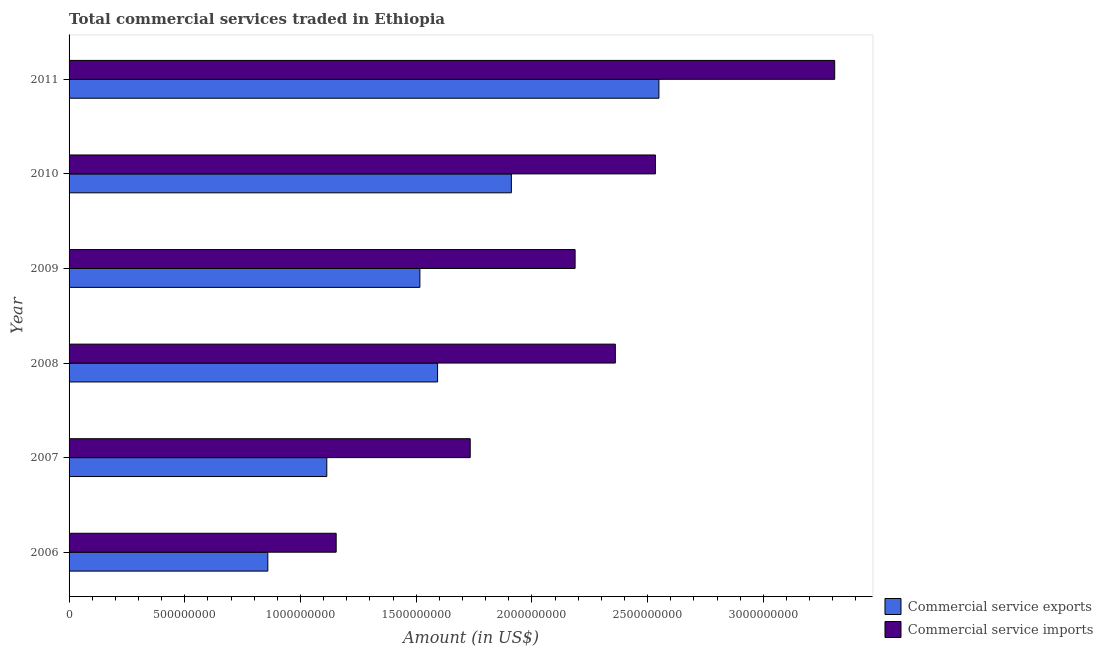How many groups of bars are there?
Offer a terse response. 6. How many bars are there on the 3rd tick from the bottom?
Make the answer very short. 2. What is the amount of commercial service exports in 2009?
Your answer should be very brief. 1.52e+09. Across all years, what is the maximum amount of commercial service imports?
Provide a short and direct response. 3.31e+09. Across all years, what is the minimum amount of commercial service exports?
Your answer should be very brief. 8.59e+08. In which year was the amount of commercial service exports minimum?
Make the answer very short. 2006. What is the total amount of commercial service exports in the graph?
Ensure brevity in your answer.  9.54e+09. What is the difference between the amount of commercial service exports in 2007 and that in 2008?
Your response must be concise. -4.79e+08. What is the difference between the amount of commercial service exports in 2006 and the amount of commercial service imports in 2010?
Keep it short and to the point. -1.67e+09. What is the average amount of commercial service imports per year?
Keep it short and to the point. 2.21e+09. In the year 2009, what is the difference between the amount of commercial service exports and amount of commercial service imports?
Give a very brief answer. -6.71e+08. What is the ratio of the amount of commercial service exports in 2008 to that in 2009?
Your answer should be very brief. 1.05. What is the difference between the highest and the second highest amount of commercial service exports?
Provide a short and direct response. 6.38e+08. What is the difference between the highest and the lowest amount of commercial service exports?
Make the answer very short. 1.69e+09. What does the 1st bar from the top in 2010 represents?
Make the answer very short. Commercial service imports. What does the 2nd bar from the bottom in 2007 represents?
Your response must be concise. Commercial service imports. How many bars are there?
Offer a very short reply. 12. Are all the bars in the graph horizontal?
Offer a terse response. Yes. How many years are there in the graph?
Make the answer very short. 6. Are the values on the major ticks of X-axis written in scientific E-notation?
Your answer should be compact. No. How are the legend labels stacked?
Your answer should be very brief. Vertical. What is the title of the graph?
Ensure brevity in your answer.  Total commercial services traded in Ethiopia. Does "Techinal cooperation" appear as one of the legend labels in the graph?
Make the answer very short. No. What is the label or title of the Y-axis?
Offer a very short reply. Year. What is the Amount (in US$) in Commercial service exports in 2006?
Ensure brevity in your answer.  8.59e+08. What is the Amount (in US$) in Commercial service imports in 2006?
Give a very brief answer. 1.15e+09. What is the Amount (in US$) in Commercial service exports in 2007?
Offer a terse response. 1.11e+09. What is the Amount (in US$) in Commercial service imports in 2007?
Ensure brevity in your answer.  1.73e+09. What is the Amount (in US$) in Commercial service exports in 2008?
Offer a terse response. 1.59e+09. What is the Amount (in US$) of Commercial service imports in 2008?
Offer a very short reply. 2.36e+09. What is the Amount (in US$) in Commercial service exports in 2009?
Provide a short and direct response. 1.52e+09. What is the Amount (in US$) of Commercial service imports in 2009?
Ensure brevity in your answer.  2.19e+09. What is the Amount (in US$) in Commercial service exports in 2010?
Ensure brevity in your answer.  1.91e+09. What is the Amount (in US$) of Commercial service imports in 2010?
Keep it short and to the point. 2.53e+09. What is the Amount (in US$) of Commercial service exports in 2011?
Ensure brevity in your answer.  2.55e+09. What is the Amount (in US$) of Commercial service imports in 2011?
Provide a succinct answer. 3.31e+09. Across all years, what is the maximum Amount (in US$) in Commercial service exports?
Offer a terse response. 2.55e+09. Across all years, what is the maximum Amount (in US$) in Commercial service imports?
Keep it short and to the point. 3.31e+09. Across all years, what is the minimum Amount (in US$) of Commercial service exports?
Offer a very short reply. 8.59e+08. Across all years, what is the minimum Amount (in US$) in Commercial service imports?
Provide a succinct answer. 1.15e+09. What is the total Amount (in US$) in Commercial service exports in the graph?
Offer a terse response. 9.54e+09. What is the total Amount (in US$) in Commercial service imports in the graph?
Your response must be concise. 1.33e+1. What is the difference between the Amount (in US$) in Commercial service exports in 2006 and that in 2007?
Provide a short and direct response. -2.55e+08. What is the difference between the Amount (in US$) of Commercial service imports in 2006 and that in 2007?
Provide a succinct answer. -5.79e+08. What is the difference between the Amount (in US$) in Commercial service exports in 2006 and that in 2008?
Keep it short and to the point. -7.34e+08. What is the difference between the Amount (in US$) of Commercial service imports in 2006 and that in 2008?
Provide a short and direct response. -1.21e+09. What is the difference between the Amount (in US$) in Commercial service exports in 2006 and that in 2009?
Keep it short and to the point. -6.57e+08. What is the difference between the Amount (in US$) of Commercial service imports in 2006 and that in 2009?
Give a very brief answer. -1.03e+09. What is the difference between the Amount (in US$) in Commercial service exports in 2006 and that in 2010?
Keep it short and to the point. -1.05e+09. What is the difference between the Amount (in US$) in Commercial service imports in 2006 and that in 2010?
Provide a succinct answer. -1.38e+09. What is the difference between the Amount (in US$) of Commercial service exports in 2006 and that in 2011?
Provide a short and direct response. -1.69e+09. What is the difference between the Amount (in US$) in Commercial service imports in 2006 and that in 2011?
Your response must be concise. -2.15e+09. What is the difference between the Amount (in US$) of Commercial service exports in 2007 and that in 2008?
Your response must be concise. -4.79e+08. What is the difference between the Amount (in US$) in Commercial service imports in 2007 and that in 2008?
Ensure brevity in your answer.  -6.27e+08. What is the difference between the Amount (in US$) in Commercial service exports in 2007 and that in 2009?
Give a very brief answer. -4.02e+08. What is the difference between the Amount (in US$) in Commercial service imports in 2007 and that in 2009?
Offer a terse response. -4.53e+08. What is the difference between the Amount (in US$) of Commercial service exports in 2007 and that in 2010?
Make the answer very short. -7.98e+08. What is the difference between the Amount (in US$) of Commercial service imports in 2007 and that in 2010?
Give a very brief answer. -8.00e+08. What is the difference between the Amount (in US$) of Commercial service exports in 2007 and that in 2011?
Your response must be concise. -1.44e+09. What is the difference between the Amount (in US$) in Commercial service imports in 2007 and that in 2011?
Offer a very short reply. -1.58e+09. What is the difference between the Amount (in US$) in Commercial service exports in 2008 and that in 2009?
Offer a terse response. 7.64e+07. What is the difference between the Amount (in US$) of Commercial service imports in 2008 and that in 2009?
Offer a terse response. 1.74e+08. What is the difference between the Amount (in US$) in Commercial service exports in 2008 and that in 2010?
Your answer should be compact. -3.19e+08. What is the difference between the Amount (in US$) in Commercial service imports in 2008 and that in 2010?
Provide a short and direct response. -1.73e+08. What is the difference between the Amount (in US$) in Commercial service exports in 2008 and that in 2011?
Provide a succinct answer. -9.56e+08. What is the difference between the Amount (in US$) of Commercial service imports in 2008 and that in 2011?
Keep it short and to the point. -9.48e+08. What is the difference between the Amount (in US$) of Commercial service exports in 2009 and that in 2010?
Offer a very short reply. -3.95e+08. What is the difference between the Amount (in US$) in Commercial service imports in 2009 and that in 2010?
Ensure brevity in your answer.  -3.47e+08. What is the difference between the Amount (in US$) in Commercial service exports in 2009 and that in 2011?
Offer a very short reply. -1.03e+09. What is the difference between the Amount (in US$) in Commercial service imports in 2009 and that in 2011?
Provide a short and direct response. -1.12e+09. What is the difference between the Amount (in US$) in Commercial service exports in 2010 and that in 2011?
Keep it short and to the point. -6.38e+08. What is the difference between the Amount (in US$) in Commercial service imports in 2010 and that in 2011?
Offer a terse response. -7.75e+08. What is the difference between the Amount (in US$) in Commercial service exports in 2006 and the Amount (in US$) in Commercial service imports in 2007?
Make the answer very short. -8.75e+08. What is the difference between the Amount (in US$) in Commercial service exports in 2006 and the Amount (in US$) in Commercial service imports in 2008?
Give a very brief answer. -1.50e+09. What is the difference between the Amount (in US$) of Commercial service exports in 2006 and the Amount (in US$) of Commercial service imports in 2009?
Keep it short and to the point. -1.33e+09. What is the difference between the Amount (in US$) in Commercial service exports in 2006 and the Amount (in US$) in Commercial service imports in 2010?
Offer a very short reply. -1.67e+09. What is the difference between the Amount (in US$) in Commercial service exports in 2006 and the Amount (in US$) in Commercial service imports in 2011?
Your answer should be very brief. -2.45e+09. What is the difference between the Amount (in US$) in Commercial service exports in 2007 and the Amount (in US$) in Commercial service imports in 2008?
Provide a short and direct response. -1.25e+09. What is the difference between the Amount (in US$) in Commercial service exports in 2007 and the Amount (in US$) in Commercial service imports in 2009?
Your answer should be compact. -1.07e+09. What is the difference between the Amount (in US$) of Commercial service exports in 2007 and the Amount (in US$) of Commercial service imports in 2010?
Provide a short and direct response. -1.42e+09. What is the difference between the Amount (in US$) of Commercial service exports in 2007 and the Amount (in US$) of Commercial service imports in 2011?
Ensure brevity in your answer.  -2.19e+09. What is the difference between the Amount (in US$) of Commercial service exports in 2008 and the Amount (in US$) of Commercial service imports in 2009?
Offer a terse response. -5.94e+08. What is the difference between the Amount (in US$) of Commercial service exports in 2008 and the Amount (in US$) of Commercial service imports in 2010?
Offer a very short reply. -9.41e+08. What is the difference between the Amount (in US$) in Commercial service exports in 2008 and the Amount (in US$) in Commercial service imports in 2011?
Give a very brief answer. -1.72e+09. What is the difference between the Amount (in US$) of Commercial service exports in 2009 and the Amount (in US$) of Commercial service imports in 2010?
Your answer should be very brief. -1.02e+09. What is the difference between the Amount (in US$) of Commercial service exports in 2009 and the Amount (in US$) of Commercial service imports in 2011?
Offer a terse response. -1.79e+09. What is the difference between the Amount (in US$) of Commercial service exports in 2010 and the Amount (in US$) of Commercial service imports in 2011?
Provide a short and direct response. -1.40e+09. What is the average Amount (in US$) of Commercial service exports per year?
Offer a terse response. 1.59e+09. What is the average Amount (in US$) in Commercial service imports per year?
Your answer should be compact. 2.21e+09. In the year 2006, what is the difference between the Amount (in US$) in Commercial service exports and Amount (in US$) in Commercial service imports?
Your answer should be compact. -2.95e+08. In the year 2007, what is the difference between the Amount (in US$) of Commercial service exports and Amount (in US$) of Commercial service imports?
Ensure brevity in your answer.  -6.20e+08. In the year 2008, what is the difference between the Amount (in US$) in Commercial service exports and Amount (in US$) in Commercial service imports?
Keep it short and to the point. -7.68e+08. In the year 2009, what is the difference between the Amount (in US$) in Commercial service exports and Amount (in US$) in Commercial service imports?
Offer a terse response. -6.71e+08. In the year 2010, what is the difference between the Amount (in US$) in Commercial service exports and Amount (in US$) in Commercial service imports?
Offer a terse response. -6.22e+08. In the year 2011, what is the difference between the Amount (in US$) in Commercial service exports and Amount (in US$) in Commercial service imports?
Make the answer very short. -7.60e+08. What is the ratio of the Amount (in US$) of Commercial service exports in 2006 to that in 2007?
Give a very brief answer. 0.77. What is the ratio of the Amount (in US$) in Commercial service imports in 2006 to that in 2007?
Provide a short and direct response. 0.67. What is the ratio of the Amount (in US$) in Commercial service exports in 2006 to that in 2008?
Offer a very short reply. 0.54. What is the ratio of the Amount (in US$) of Commercial service imports in 2006 to that in 2008?
Give a very brief answer. 0.49. What is the ratio of the Amount (in US$) of Commercial service exports in 2006 to that in 2009?
Your response must be concise. 0.57. What is the ratio of the Amount (in US$) in Commercial service imports in 2006 to that in 2009?
Your answer should be very brief. 0.53. What is the ratio of the Amount (in US$) of Commercial service exports in 2006 to that in 2010?
Offer a terse response. 0.45. What is the ratio of the Amount (in US$) in Commercial service imports in 2006 to that in 2010?
Provide a succinct answer. 0.46. What is the ratio of the Amount (in US$) of Commercial service exports in 2006 to that in 2011?
Offer a terse response. 0.34. What is the ratio of the Amount (in US$) in Commercial service imports in 2006 to that in 2011?
Make the answer very short. 0.35. What is the ratio of the Amount (in US$) of Commercial service exports in 2007 to that in 2008?
Your answer should be compact. 0.7. What is the ratio of the Amount (in US$) in Commercial service imports in 2007 to that in 2008?
Offer a terse response. 0.73. What is the ratio of the Amount (in US$) of Commercial service exports in 2007 to that in 2009?
Your response must be concise. 0.73. What is the ratio of the Amount (in US$) of Commercial service imports in 2007 to that in 2009?
Provide a short and direct response. 0.79. What is the ratio of the Amount (in US$) of Commercial service exports in 2007 to that in 2010?
Your answer should be very brief. 0.58. What is the ratio of the Amount (in US$) in Commercial service imports in 2007 to that in 2010?
Your answer should be very brief. 0.68. What is the ratio of the Amount (in US$) in Commercial service exports in 2007 to that in 2011?
Make the answer very short. 0.44. What is the ratio of the Amount (in US$) of Commercial service imports in 2007 to that in 2011?
Your response must be concise. 0.52. What is the ratio of the Amount (in US$) in Commercial service exports in 2008 to that in 2009?
Offer a very short reply. 1.05. What is the ratio of the Amount (in US$) in Commercial service imports in 2008 to that in 2009?
Your answer should be compact. 1.08. What is the ratio of the Amount (in US$) of Commercial service exports in 2008 to that in 2010?
Your answer should be compact. 0.83. What is the ratio of the Amount (in US$) of Commercial service imports in 2008 to that in 2010?
Your answer should be very brief. 0.93. What is the ratio of the Amount (in US$) of Commercial service exports in 2008 to that in 2011?
Provide a succinct answer. 0.62. What is the ratio of the Amount (in US$) in Commercial service imports in 2008 to that in 2011?
Offer a terse response. 0.71. What is the ratio of the Amount (in US$) of Commercial service exports in 2009 to that in 2010?
Offer a very short reply. 0.79. What is the ratio of the Amount (in US$) of Commercial service imports in 2009 to that in 2010?
Your answer should be compact. 0.86. What is the ratio of the Amount (in US$) in Commercial service exports in 2009 to that in 2011?
Give a very brief answer. 0.59. What is the ratio of the Amount (in US$) of Commercial service imports in 2009 to that in 2011?
Make the answer very short. 0.66. What is the ratio of the Amount (in US$) of Commercial service exports in 2010 to that in 2011?
Offer a very short reply. 0.75. What is the ratio of the Amount (in US$) in Commercial service imports in 2010 to that in 2011?
Keep it short and to the point. 0.77. What is the difference between the highest and the second highest Amount (in US$) of Commercial service exports?
Provide a succinct answer. 6.38e+08. What is the difference between the highest and the second highest Amount (in US$) of Commercial service imports?
Provide a short and direct response. 7.75e+08. What is the difference between the highest and the lowest Amount (in US$) of Commercial service exports?
Ensure brevity in your answer.  1.69e+09. What is the difference between the highest and the lowest Amount (in US$) of Commercial service imports?
Make the answer very short. 2.15e+09. 